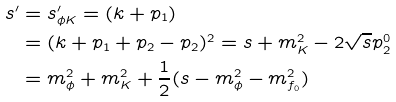Convert formula to latex. <formula><loc_0><loc_0><loc_500><loc_500>s ^ { \prime } & = s ^ { \prime } _ { \phi K } = ( k + p _ { 1 } ) \\ & = ( k + p _ { 1 } + p _ { 2 } - p _ { 2 } ) ^ { 2 } = s + m ^ { 2 } _ { K } - 2 \sqrt { s } p ^ { 0 } _ { 2 } \\ & = m ^ { 2 } _ { \phi } + m ^ { 2 } _ { K } + \frac { 1 } { 2 } ( s - m ^ { 2 } _ { \phi } - m ^ { 2 } _ { f _ { 0 } } )</formula> 